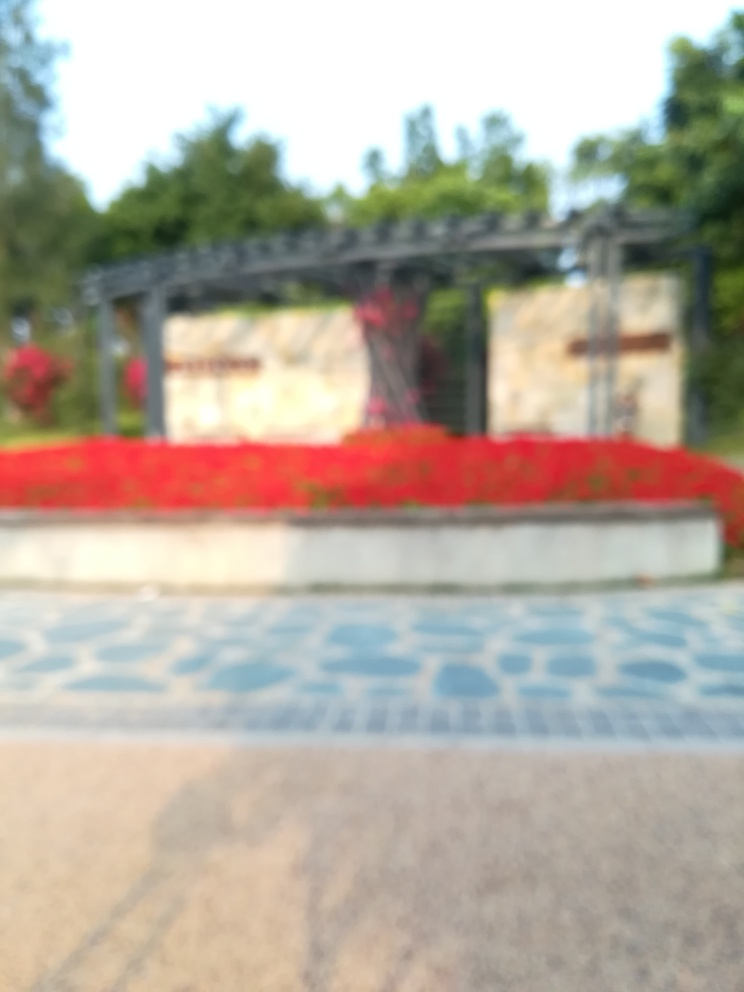Is there strong lighting in the image? It's challenging to confirm the exact lighting conditions due to the image's blurred quality. However, it appears that the scene is evenly lit, indicating there could be a strong natural light source, such as daylight, contributing to the visibility, albeit the specifics cannot be discerned with certainty. 